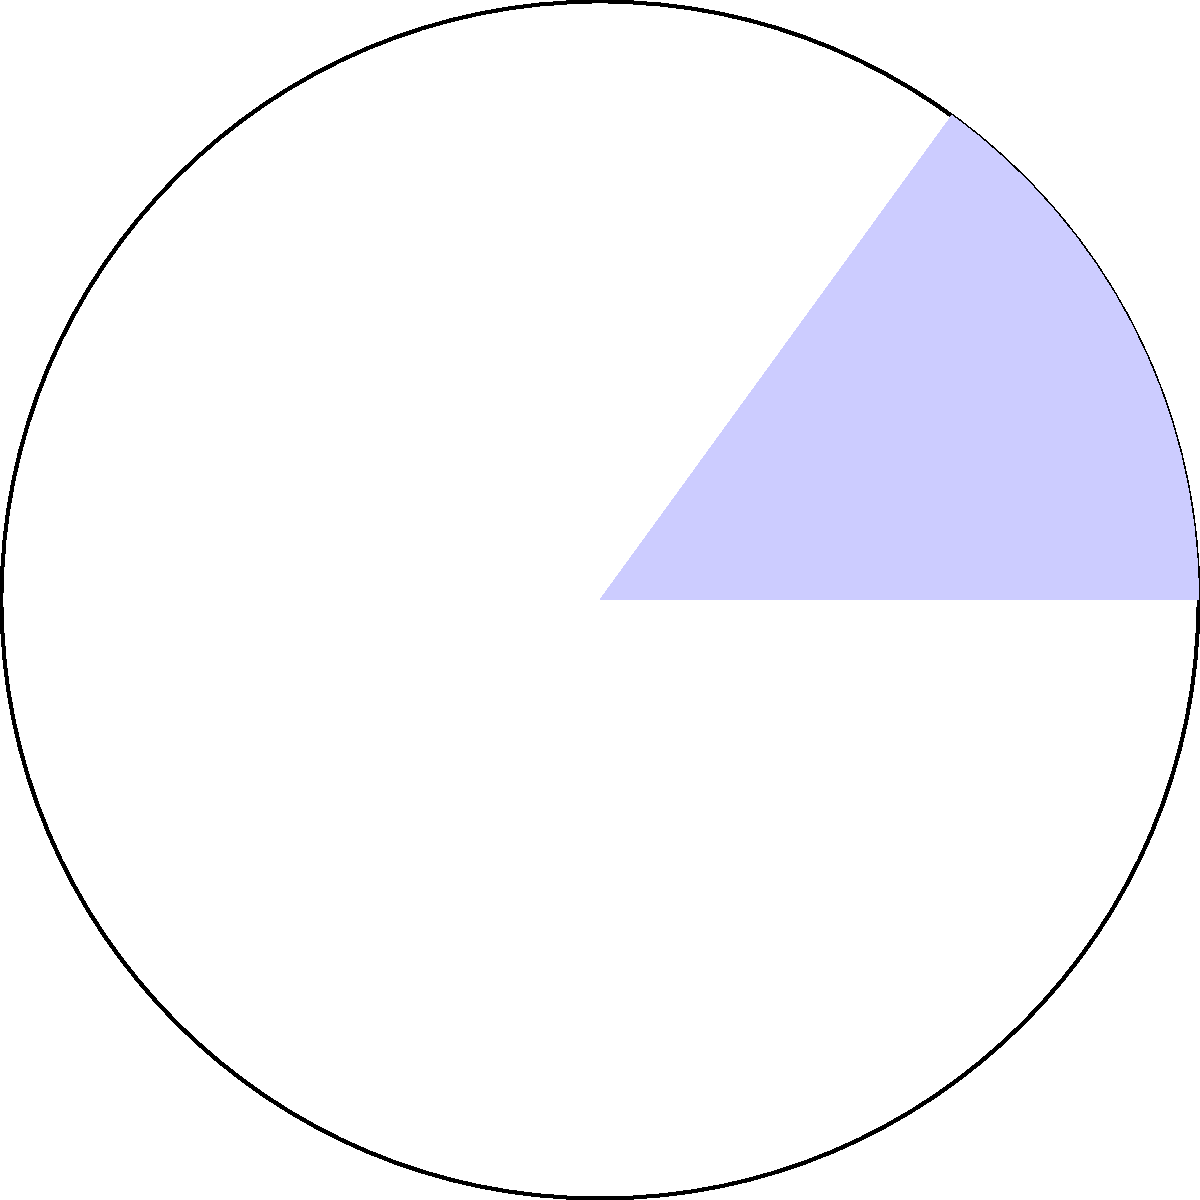In a recent competition, it was found that 15% of athletes were using hormone therapy to enhance their performance. If this percentage is represented by a sector in a circular diagram, what is the measure of the central angle of this sector? To find the central angle of the sector representing the percentage of athletes using hormone therapy, we can follow these steps:

1) Recall that a full circle contains 360°.

2) Set up a proportion to relate the percentage to the angle:
   $$\frac{\text{Percentage}}{100\%} = \frac{\text{Central Angle}}{360°}$$

3) Substitute the given percentage (15%) into the equation:
   $$\frac{15\%}{100\%} = \frac{\text{Central Angle}}{360°}$$

4) Cross multiply:
   $$15 \times 360° = 100 \times \text{Central Angle}$$

5) Solve for the Central Angle:
   $$5400° = 100 \times \text{Central Angle}$$
   $$\text{Central Angle} = \frac{5400°}{100} = 54°$$

Therefore, the central angle of the sector representing 15% of the circle is 54°.
Answer: 54° 